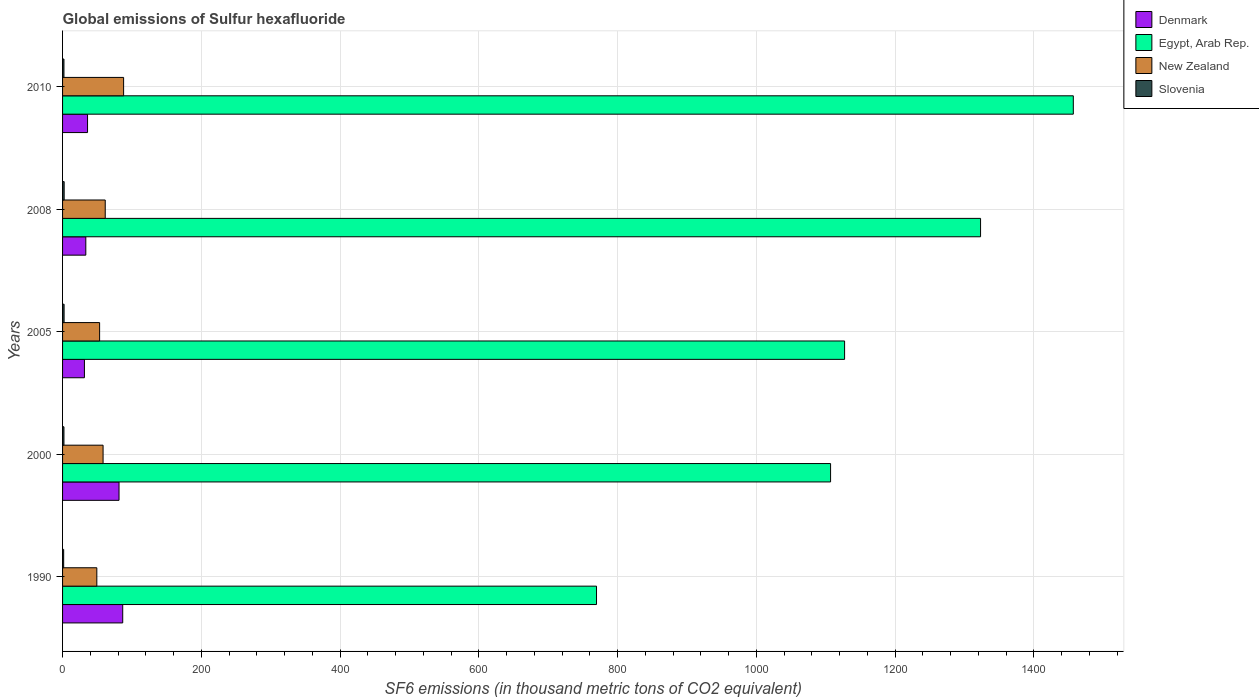How many different coloured bars are there?
Provide a succinct answer. 4. How many groups of bars are there?
Keep it short and to the point. 5. What is the label of the 1st group of bars from the top?
Your answer should be very brief. 2010. Across all years, what is the maximum global emissions of Sulfur hexafluoride in Slovenia?
Provide a succinct answer. 2.3. Across all years, what is the minimum global emissions of Sulfur hexafluoride in New Zealand?
Provide a succinct answer. 49.4. In which year was the global emissions of Sulfur hexafluoride in New Zealand maximum?
Offer a very short reply. 2010. What is the total global emissions of Sulfur hexafluoride in Egypt, Arab Rep. in the graph?
Offer a very short reply. 5784.4. What is the difference between the global emissions of Sulfur hexafluoride in Egypt, Arab Rep. in 1990 and the global emissions of Sulfur hexafluoride in Denmark in 2010?
Keep it short and to the point. 733.7. What is the average global emissions of Sulfur hexafluoride in Slovenia per year?
Offer a terse response. 2.02. In the year 2010, what is the difference between the global emissions of Sulfur hexafluoride in Denmark and global emissions of Sulfur hexafluoride in Egypt, Arab Rep.?
Offer a terse response. -1421. In how many years, is the global emissions of Sulfur hexafluoride in Denmark greater than 600 thousand metric tons?
Offer a very short reply. 0. What is the ratio of the global emissions of Sulfur hexafluoride in Slovenia in 2000 to that in 2005?
Provide a short and direct response. 0.91. Is the global emissions of Sulfur hexafluoride in Slovenia in 2008 less than that in 2010?
Provide a succinct answer. No. Is the difference between the global emissions of Sulfur hexafluoride in Denmark in 2000 and 2008 greater than the difference between the global emissions of Sulfur hexafluoride in Egypt, Arab Rep. in 2000 and 2008?
Keep it short and to the point. Yes. What is the difference between the highest and the second highest global emissions of Sulfur hexafluoride in Egypt, Arab Rep.?
Your response must be concise. 133.7. What is the difference between the highest and the lowest global emissions of Sulfur hexafluoride in Egypt, Arab Rep.?
Ensure brevity in your answer.  687.3. In how many years, is the global emissions of Sulfur hexafluoride in Slovenia greater than the average global emissions of Sulfur hexafluoride in Slovenia taken over all years?
Give a very brief answer. 2. Is the sum of the global emissions of Sulfur hexafluoride in Slovenia in 1990 and 2008 greater than the maximum global emissions of Sulfur hexafluoride in New Zealand across all years?
Offer a terse response. No. What does the 4th bar from the top in 2010 represents?
Ensure brevity in your answer.  Denmark. What does the 3rd bar from the bottom in 1990 represents?
Give a very brief answer. New Zealand. Is it the case that in every year, the sum of the global emissions of Sulfur hexafluoride in Egypt, Arab Rep. and global emissions of Sulfur hexafluoride in New Zealand is greater than the global emissions of Sulfur hexafluoride in Slovenia?
Make the answer very short. Yes. How many bars are there?
Offer a terse response. 20. Are all the bars in the graph horizontal?
Offer a very short reply. Yes. How many years are there in the graph?
Make the answer very short. 5. What is the difference between two consecutive major ticks on the X-axis?
Provide a short and direct response. 200. Are the values on the major ticks of X-axis written in scientific E-notation?
Ensure brevity in your answer.  No. Does the graph contain any zero values?
Your response must be concise. No. Where does the legend appear in the graph?
Your response must be concise. Top right. How many legend labels are there?
Your answer should be compact. 4. How are the legend labels stacked?
Provide a short and direct response. Vertical. What is the title of the graph?
Offer a terse response. Global emissions of Sulfur hexafluoride. What is the label or title of the X-axis?
Give a very brief answer. SF6 emissions (in thousand metric tons of CO2 equivalent). What is the label or title of the Y-axis?
Make the answer very short. Years. What is the SF6 emissions (in thousand metric tons of CO2 equivalent) in Denmark in 1990?
Provide a short and direct response. 86.7. What is the SF6 emissions (in thousand metric tons of CO2 equivalent) in Egypt, Arab Rep. in 1990?
Your answer should be very brief. 769.7. What is the SF6 emissions (in thousand metric tons of CO2 equivalent) of New Zealand in 1990?
Offer a very short reply. 49.4. What is the SF6 emissions (in thousand metric tons of CO2 equivalent) of Slovenia in 1990?
Provide a short and direct response. 1.6. What is the SF6 emissions (in thousand metric tons of CO2 equivalent) of Denmark in 2000?
Give a very brief answer. 81.4. What is the SF6 emissions (in thousand metric tons of CO2 equivalent) in Egypt, Arab Rep. in 2000?
Make the answer very short. 1107.1. What is the SF6 emissions (in thousand metric tons of CO2 equivalent) in New Zealand in 2000?
Keep it short and to the point. 58.4. What is the SF6 emissions (in thousand metric tons of CO2 equivalent) of Denmark in 2005?
Your response must be concise. 31.5. What is the SF6 emissions (in thousand metric tons of CO2 equivalent) in Egypt, Arab Rep. in 2005?
Offer a very short reply. 1127.3. What is the SF6 emissions (in thousand metric tons of CO2 equivalent) of New Zealand in 2005?
Your response must be concise. 53.4. What is the SF6 emissions (in thousand metric tons of CO2 equivalent) of Slovenia in 2005?
Provide a succinct answer. 2.2. What is the SF6 emissions (in thousand metric tons of CO2 equivalent) of Denmark in 2008?
Provide a succinct answer. 33.5. What is the SF6 emissions (in thousand metric tons of CO2 equivalent) in Egypt, Arab Rep. in 2008?
Offer a very short reply. 1323.3. What is the SF6 emissions (in thousand metric tons of CO2 equivalent) in New Zealand in 2008?
Make the answer very short. 61.5. What is the SF6 emissions (in thousand metric tons of CO2 equivalent) of Egypt, Arab Rep. in 2010?
Keep it short and to the point. 1457. What is the SF6 emissions (in thousand metric tons of CO2 equivalent) of Slovenia in 2010?
Offer a very short reply. 2. Across all years, what is the maximum SF6 emissions (in thousand metric tons of CO2 equivalent) of Denmark?
Provide a succinct answer. 86.7. Across all years, what is the maximum SF6 emissions (in thousand metric tons of CO2 equivalent) of Egypt, Arab Rep.?
Provide a short and direct response. 1457. Across all years, what is the minimum SF6 emissions (in thousand metric tons of CO2 equivalent) in Denmark?
Your answer should be very brief. 31.5. Across all years, what is the minimum SF6 emissions (in thousand metric tons of CO2 equivalent) of Egypt, Arab Rep.?
Provide a short and direct response. 769.7. Across all years, what is the minimum SF6 emissions (in thousand metric tons of CO2 equivalent) in New Zealand?
Make the answer very short. 49.4. What is the total SF6 emissions (in thousand metric tons of CO2 equivalent) of Denmark in the graph?
Offer a very short reply. 269.1. What is the total SF6 emissions (in thousand metric tons of CO2 equivalent) in Egypt, Arab Rep. in the graph?
Ensure brevity in your answer.  5784.4. What is the total SF6 emissions (in thousand metric tons of CO2 equivalent) of New Zealand in the graph?
Offer a terse response. 310.7. What is the difference between the SF6 emissions (in thousand metric tons of CO2 equivalent) of Denmark in 1990 and that in 2000?
Make the answer very short. 5.3. What is the difference between the SF6 emissions (in thousand metric tons of CO2 equivalent) in Egypt, Arab Rep. in 1990 and that in 2000?
Make the answer very short. -337.4. What is the difference between the SF6 emissions (in thousand metric tons of CO2 equivalent) of New Zealand in 1990 and that in 2000?
Your answer should be compact. -9. What is the difference between the SF6 emissions (in thousand metric tons of CO2 equivalent) of Slovenia in 1990 and that in 2000?
Ensure brevity in your answer.  -0.4. What is the difference between the SF6 emissions (in thousand metric tons of CO2 equivalent) in Denmark in 1990 and that in 2005?
Keep it short and to the point. 55.2. What is the difference between the SF6 emissions (in thousand metric tons of CO2 equivalent) of Egypt, Arab Rep. in 1990 and that in 2005?
Your answer should be very brief. -357.6. What is the difference between the SF6 emissions (in thousand metric tons of CO2 equivalent) in New Zealand in 1990 and that in 2005?
Provide a short and direct response. -4. What is the difference between the SF6 emissions (in thousand metric tons of CO2 equivalent) in Slovenia in 1990 and that in 2005?
Provide a succinct answer. -0.6. What is the difference between the SF6 emissions (in thousand metric tons of CO2 equivalent) in Denmark in 1990 and that in 2008?
Offer a terse response. 53.2. What is the difference between the SF6 emissions (in thousand metric tons of CO2 equivalent) of Egypt, Arab Rep. in 1990 and that in 2008?
Your response must be concise. -553.6. What is the difference between the SF6 emissions (in thousand metric tons of CO2 equivalent) of New Zealand in 1990 and that in 2008?
Keep it short and to the point. -12.1. What is the difference between the SF6 emissions (in thousand metric tons of CO2 equivalent) of Slovenia in 1990 and that in 2008?
Your answer should be very brief. -0.7. What is the difference between the SF6 emissions (in thousand metric tons of CO2 equivalent) of Denmark in 1990 and that in 2010?
Make the answer very short. 50.7. What is the difference between the SF6 emissions (in thousand metric tons of CO2 equivalent) of Egypt, Arab Rep. in 1990 and that in 2010?
Offer a terse response. -687.3. What is the difference between the SF6 emissions (in thousand metric tons of CO2 equivalent) of New Zealand in 1990 and that in 2010?
Make the answer very short. -38.6. What is the difference between the SF6 emissions (in thousand metric tons of CO2 equivalent) in Slovenia in 1990 and that in 2010?
Your response must be concise. -0.4. What is the difference between the SF6 emissions (in thousand metric tons of CO2 equivalent) of Denmark in 2000 and that in 2005?
Give a very brief answer. 49.9. What is the difference between the SF6 emissions (in thousand metric tons of CO2 equivalent) in Egypt, Arab Rep. in 2000 and that in 2005?
Your answer should be very brief. -20.2. What is the difference between the SF6 emissions (in thousand metric tons of CO2 equivalent) in Slovenia in 2000 and that in 2005?
Offer a terse response. -0.2. What is the difference between the SF6 emissions (in thousand metric tons of CO2 equivalent) of Denmark in 2000 and that in 2008?
Provide a short and direct response. 47.9. What is the difference between the SF6 emissions (in thousand metric tons of CO2 equivalent) in Egypt, Arab Rep. in 2000 and that in 2008?
Ensure brevity in your answer.  -216.2. What is the difference between the SF6 emissions (in thousand metric tons of CO2 equivalent) in New Zealand in 2000 and that in 2008?
Provide a short and direct response. -3.1. What is the difference between the SF6 emissions (in thousand metric tons of CO2 equivalent) in Slovenia in 2000 and that in 2008?
Provide a succinct answer. -0.3. What is the difference between the SF6 emissions (in thousand metric tons of CO2 equivalent) of Denmark in 2000 and that in 2010?
Offer a very short reply. 45.4. What is the difference between the SF6 emissions (in thousand metric tons of CO2 equivalent) of Egypt, Arab Rep. in 2000 and that in 2010?
Make the answer very short. -349.9. What is the difference between the SF6 emissions (in thousand metric tons of CO2 equivalent) in New Zealand in 2000 and that in 2010?
Provide a short and direct response. -29.6. What is the difference between the SF6 emissions (in thousand metric tons of CO2 equivalent) of Slovenia in 2000 and that in 2010?
Make the answer very short. 0. What is the difference between the SF6 emissions (in thousand metric tons of CO2 equivalent) of Egypt, Arab Rep. in 2005 and that in 2008?
Provide a succinct answer. -196. What is the difference between the SF6 emissions (in thousand metric tons of CO2 equivalent) of New Zealand in 2005 and that in 2008?
Provide a succinct answer. -8.1. What is the difference between the SF6 emissions (in thousand metric tons of CO2 equivalent) in Denmark in 2005 and that in 2010?
Your answer should be compact. -4.5. What is the difference between the SF6 emissions (in thousand metric tons of CO2 equivalent) of Egypt, Arab Rep. in 2005 and that in 2010?
Your answer should be very brief. -329.7. What is the difference between the SF6 emissions (in thousand metric tons of CO2 equivalent) of New Zealand in 2005 and that in 2010?
Provide a succinct answer. -34.6. What is the difference between the SF6 emissions (in thousand metric tons of CO2 equivalent) in Slovenia in 2005 and that in 2010?
Provide a succinct answer. 0.2. What is the difference between the SF6 emissions (in thousand metric tons of CO2 equivalent) of Denmark in 2008 and that in 2010?
Offer a terse response. -2.5. What is the difference between the SF6 emissions (in thousand metric tons of CO2 equivalent) in Egypt, Arab Rep. in 2008 and that in 2010?
Make the answer very short. -133.7. What is the difference between the SF6 emissions (in thousand metric tons of CO2 equivalent) of New Zealand in 2008 and that in 2010?
Offer a terse response. -26.5. What is the difference between the SF6 emissions (in thousand metric tons of CO2 equivalent) of Denmark in 1990 and the SF6 emissions (in thousand metric tons of CO2 equivalent) of Egypt, Arab Rep. in 2000?
Your answer should be very brief. -1020.4. What is the difference between the SF6 emissions (in thousand metric tons of CO2 equivalent) of Denmark in 1990 and the SF6 emissions (in thousand metric tons of CO2 equivalent) of New Zealand in 2000?
Ensure brevity in your answer.  28.3. What is the difference between the SF6 emissions (in thousand metric tons of CO2 equivalent) of Denmark in 1990 and the SF6 emissions (in thousand metric tons of CO2 equivalent) of Slovenia in 2000?
Give a very brief answer. 84.7. What is the difference between the SF6 emissions (in thousand metric tons of CO2 equivalent) in Egypt, Arab Rep. in 1990 and the SF6 emissions (in thousand metric tons of CO2 equivalent) in New Zealand in 2000?
Offer a terse response. 711.3. What is the difference between the SF6 emissions (in thousand metric tons of CO2 equivalent) in Egypt, Arab Rep. in 1990 and the SF6 emissions (in thousand metric tons of CO2 equivalent) in Slovenia in 2000?
Your answer should be compact. 767.7. What is the difference between the SF6 emissions (in thousand metric tons of CO2 equivalent) in New Zealand in 1990 and the SF6 emissions (in thousand metric tons of CO2 equivalent) in Slovenia in 2000?
Provide a succinct answer. 47.4. What is the difference between the SF6 emissions (in thousand metric tons of CO2 equivalent) of Denmark in 1990 and the SF6 emissions (in thousand metric tons of CO2 equivalent) of Egypt, Arab Rep. in 2005?
Your answer should be very brief. -1040.6. What is the difference between the SF6 emissions (in thousand metric tons of CO2 equivalent) in Denmark in 1990 and the SF6 emissions (in thousand metric tons of CO2 equivalent) in New Zealand in 2005?
Give a very brief answer. 33.3. What is the difference between the SF6 emissions (in thousand metric tons of CO2 equivalent) of Denmark in 1990 and the SF6 emissions (in thousand metric tons of CO2 equivalent) of Slovenia in 2005?
Offer a terse response. 84.5. What is the difference between the SF6 emissions (in thousand metric tons of CO2 equivalent) of Egypt, Arab Rep. in 1990 and the SF6 emissions (in thousand metric tons of CO2 equivalent) of New Zealand in 2005?
Your response must be concise. 716.3. What is the difference between the SF6 emissions (in thousand metric tons of CO2 equivalent) of Egypt, Arab Rep. in 1990 and the SF6 emissions (in thousand metric tons of CO2 equivalent) of Slovenia in 2005?
Offer a very short reply. 767.5. What is the difference between the SF6 emissions (in thousand metric tons of CO2 equivalent) in New Zealand in 1990 and the SF6 emissions (in thousand metric tons of CO2 equivalent) in Slovenia in 2005?
Your answer should be compact. 47.2. What is the difference between the SF6 emissions (in thousand metric tons of CO2 equivalent) in Denmark in 1990 and the SF6 emissions (in thousand metric tons of CO2 equivalent) in Egypt, Arab Rep. in 2008?
Offer a very short reply. -1236.6. What is the difference between the SF6 emissions (in thousand metric tons of CO2 equivalent) in Denmark in 1990 and the SF6 emissions (in thousand metric tons of CO2 equivalent) in New Zealand in 2008?
Make the answer very short. 25.2. What is the difference between the SF6 emissions (in thousand metric tons of CO2 equivalent) of Denmark in 1990 and the SF6 emissions (in thousand metric tons of CO2 equivalent) of Slovenia in 2008?
Your response must be concise. 84.4. What is the difference between the SF6 emissions (in thousand metric tons of CO2 equivalent) in Egypt, Arab Rep. in 1990 and the SF6 emissions (in thousand metric tons of CO2 equivalent) in New Zealand in 2008?
Make the answer very short. 708.2. What is the difference between the SF6 emissions (in thousand metric tons of CO2 equivalent) in Egypt, Arab Rep. in 1990 and the SF6 emissions (in thousand metric tons of CO2 equivalent) in Slovenia in 2008?
Offer a terse response. 767.4. What is the difference between the SF6 emissions (in thousand metric tons of CO2 equivalent) in New Zealand in 1990 and the SF6 emissions (in thousand metric tons of CO2 equivalent) in Slovenia in 2008?
Give a very brief answer. 47.1. What is the difference between the SF6 emissions (in thousand metric tons of CO2 equivalent) in Denmark in 1990 and the SF6 emissions (in thousand metric tons of CO2 equivalent) in Egypt, Arab Rep. in 2010?
Your response must be concise. -1370.3. What is the difference between the SF6 emissions (in thousand metric tons of CO2 equivalent) of Denmark in 1990 and the SF6 emissions (in thousand metric tons of CO2 equivalent) of Slovenia in 2010?
Provide a short and direct response. 84.7. What is the difference between the SF6 emissions (in thousand metric tons of CO2 equivalent) of Egypt, Arab Rep. in 1990 and the SF6 emissions (in thousand metric tons of CO2 equivalent) of New Zealand in 2010?
Provide a short and direct response. 681.7. What is the difference between the SF6 emissions (in thousand metric tons of CO2 equivalent) in Egypt, Arab Rep. in 1990 and the SF6 emissions (in thousand metric tons of CO2 equivalent) in Slovenia in 2010?
Provide a succinct answer. 767.7. What is the difference between the SF6 emissions (in thousand metric tons of CO2 equivalent) in New Zealand in 1990 and the SF6 emissions (in thousand metric tons of CO2 equivalent) in Slovenia in 2010?
Your answer should be compact. 47.4. What is the difference between the SF6 emissions (in thousand metric tons of CO2 equivalent) in Denmark in 2000 and the SF6 emissions (in thousand metric tons of CO2 equivalent) in Egypt, Arab Rep. in 2005?
Provide a succinct answer. -1045.9. What is the difference between the SF6 emissions (in thousand metric tons of CO2 equivalent) of Denmark in 2000 and the SF6 emissions (in thousand metric tons of CO2 equivalent) of Slovenia in 2005?
Provide a short and direct response. 79.2. What is the difference between the SF6 emissions (in thousand metric tons of CO2 equivalent) in Egypt, Arab Rep. in 2000 and the SF6 emissions (in thousand metric tons of CO2 equivalent) in New Zealand in 2005?
Ensure brevity in your answer.  1053.7. What is the difference between the SF6 emissions (in thousand metric tons of CO2 equivalent) in Egypt, Arab Rep. in 2000 and the SF6 emissions (in thousand metric tons of CO2 equivalent) in Slovenia in 2005?
Provide a short and direct response. 1104.9. What is the difference between the SF6 emissions (in thousand metric tons of CO2 equivalent) of New Zealand in 2000 and the SF6 emissions (in thousand metric tons of CO2 equivalent) of Slovenia in 2005?
Give a very brief answer. 56.2. What is the difference between the SF6 emissions (in thousand metric tons of CO2 equivalent) of Denmark in 2000 and the SF6 emissions (in thousand metric tons of CO2 equivalent) of Egypt, Arab Rep. in 2008?
Your answer should be very brief. -1241.9. What is the difference between the SF6 emissions (in thousand metric tons of CO2 equivalent) in Denmark in 2000 and the SF6 emissions (in thousand metric tons of CO2 equivalent) in Slovenia in 2008?
Give a very brief answer. 79.1. What is the difference between the SF6 emissions (in thousand metric tons of CO2 equivalent) in Egypt, Arab Rep. in 2000 and the SF6 emissions (in thousand metric tons of CO2 equivalent) in New Zealand in 2008?
Your response must be concise. 1045.6. What is the difference between the SF6 emissions (in thousand metric tons of CO2 equivalent) of Egypt, Arab Rep. in 2000 and the SF6 emissions (in thousand metric tons of CO2 equivalent) of Slovenia in 2008?
Offer a terse response. 1104.8. What is the difference between the SF6 emissions (in thousand metric tons of CO2 equivalent) in New Zealand in 2000 and the SF6 emissions (in thousand metric tons of CO2 equivalent) in Slovenia in 2008?
Make the answer very short. 56.1. What is the difference between the SF6 emissions (in thousand metric tons of CO2 equivalent) in Denmark in 2000 and the SF6 emissions (in thousand metric tons of CO2 equivalent) in Egypt, Arab Rep. in 2010?
Provide a short and direct response. -1375.6. What is the difference between the SF6 emissions (in thousand metric tons of CO2 equivalent) in Denmark in 2000 and the SF6 emissions (in thousand metric tons of CO2 equivalent) in New Zealand in 2010?
Give a very brief answer. -6.6. What is the difference between the SF6 emissions (in thousand metric tons of CO2 equivalent) of Denmark in 2000 and the SF6 emissions (in thousand metric tons of CO2 equivalent) of Slovenia in 2010?
Offer a very short reply. 79.4. What is the difference between the SF6 emissions (in thousand metric tons of CO2 equivalent) in Egypt, Arab Rep. in 2000 and the SF6 emissions (in thousand metric tons of CO2 equivalent) in New Zealand in 2010?
Keep it short and to the point. 1019.1. What is the difference between the SF6 emissions (in thousand metric tons of CO2 equivalent) of Egypt, Arab Rep. in 2000 and the SF6 emissions (in thousand metric tons of CO2 equivalent) of Slovenia in 2010?
Provide a short and direct response. 1105.1. What is the difference between the SF6 emissions (in thousand metric tons of CO2 equivalent) in New Zealand in 2000 and the SF6 emissions (in thousand metric tons of CO2 equivalent) in Slovenia in 2010?
Make the answer very short. 56.4. What is the difference between the SF6 emissions (in thousand metric tons of CO2 equivalent) of Denmark in 2005 and the SF6 emissions (in thousand metric tons of CO2 equivalent) of Egypt, Arab Rep. in 2008?
Offer a terse response. -1291.8. What is the difference between the SF6 emissions (in thousand metric tons of CO2 equivalent) of Denmark in 2005 and the SF6 emissions (in thousand metric tons of CO2 equivalent) of New Zealand in 2008?
Your answer should be compact. -30. What is the difference between the SF6 emissions (in thousand metric tons of CO2 equivalent) in Denmark in 2005 and the SF6 emissions (in thousand metric tons of CO2 equivalent) in Slovenia in 2008?
Provide a succinct answer. 29.2. What is the difference between the SF6 emissions (in thousand metric tons of CO2 equivalent) in Egypt, Arab Rep. in 2005 and the SF6 emissions (in thousand metric tons of CO2 equivalent) in New Zealand in 2008?
Provide a short and direct response. 1065.8. What is the difference between the SF6 emissions (in thousand metric tons of CO2 equivalent) of Egypt, Arab Rep. in 2005 and the SF6 emissions (in thousand metric tons of CO2 equivalent) of Slovenia in 2008?
Offer a very short reply. 1125. What is the difference between the SF6 emissions (in thousand metric tons of CO2 equivalent) in New Zealand in 2005 and the SF6 emissions (in thousand metric tons of CO2 equivalent) in Slovenia in 2008?
Make the answer very short. 51.1. What is the difference between the SF6 emissions (in thousand metric tons of CO2 equivalent) of Denmark in 2005 and the SF6 emissions (in thousand metric tons of CO2 equivalent) of Egypt, Arab Rep. in 2010?
Give a very brief answer. -1425.5. What is the difference between the SF6 emissions (in thousand metric tons of CO2 equivalent) in Denmark in 2005 and the SF6 emissions (in thousand metric tons of CO2 equivalent) in New Zealand in 2010?
Keep it short and to the point. -56.5. What is the difference between the SF6 emissions (in thousand metric tons of CO2 equivalent) in Denmark in 2005 and the SF6 emissions (in thousand metric tons of CO2 equivalent) in Slovenia in 2010?
Offer a terse response. 29.5. What is the difference between the SF6 emissions (in thousand metric tons of CO2 equivalent) in Egypt, Arab Rep. in 2005 and the SF6 emissions (in thousand metric tons of CO2 equivalent) in New Zealand in 2010?
Your response must be concise. 1039.3. What is the difference between the SF6 emissions (in thousand metric tons of CO2 equivalent) in Egypt, Arab Rep. in 2005 and the SF6 emissions (in thousand metric tons of CO2 equivalent) in Slovenia in 2010?
Provide a succinct answer. 1125.3. What is the difference between the SF6 emissions (in thousand metric tons of CO2 equivalent) in New Zealand in 2005 and the SF6 emissions (in thousand metric tons of CO2 equivalent) in Slovenia in 2010?
Your answer should be very brief. 51.4. What is the difference between the SF6 emissions (in thousand metric tons of CO2 equivalent) of Denmark in 2008 and the SF6 emissions (in thousand metric tons of CO2 equivalent) of Egypt, Arab Rep. in 2010?
Offer a very short reply. -1423.5. What is the difference between the SF6 emissions (in thousand metric tons of CO2 equivalent) of Denmark in 2008 and the SF6 emissions (in thousand metric tons of CO2 equivalent) of New Zealand in 2010?
Give a very brief answer. -54.5. What is the difference between the SF6 emissions (in thousand metric tons of CO2 equivalent) of Denmark in 2008 and the SF6 emissions (in thousand metric tons of CO2 equivalent) of Slovenia in 2010?
Your response must be concise. 31.5. What is the difference between the SF6 emissions (in thousand metric tons of CO2 equivalent) in Egypt, Arab Rep. in 2008 and the SF6 emissions (in thousand metric tons of CO2 equivalent) in New Zealand in 2010?
Your answer should be very brief. 1235.3. What is the difference between the SF6 emissions (in thousand metric tons of CO2 equivalent) of Egypt, Arab Rep. in 2008 and the SF6 emissions (in thousand metric tons of CO2 equivalent) of Slovenia in 2010?
Your answer should be compact. 1321.3. What is the difference between the SF6 emissions (in thousand metric tons of CO2 equivalent) in New Zealand in 2008 and the SF6 emissions (in thousand metric tons of CO2 equivalent) in Slovenia in 2010?
Your answer should be very brief. 59.5. What is the average SF6 emissions (in thousand metric tons of CO2 equivalent) in Denmark per year?
Give a very brief answer. 53.82. What is the average SF6 emissions (in thousand metric tons of CO2 equivalent) of Egypt, Arab Rep. per year?
Offer a terse response. 1156.88. What is the average SF6 emissions (in thousand metric tons of CO2 equivalent) of New Zealand per year?
Provide a succinct answer. 62.14. What is the average SF6 emissions (in thousand metric tons of CO2 equivalent) in Slovenia per year?
Keep it short and to the point. 2.02. In the year 1990, what is the difference between the SF6 emissions (in thousand metric tons of CO2 equivalent) of Denmark and SF6 emissions (in thousand metric tons of CO2 equivalent) of Egypt, Arab Rep.?
Make the answer very short. -683. In the year 1990, what is the difference between the SF6 emissions (in thousand metric tons of CO2 equivalent) of Denmark and SF6 emissions (in thousand metric tons of CO2 equivalent) of New Zealand?
Provide a short and direct response. 37.3. In the year 1990, what is the difference between the SF6 emissions (in thousand metric tons of CO2 equivalent) of Denmark and SF6 emissions (in thousand metric tons of CO2 equivalent) of Slovenia?
Keep it short and to the point. 85.1. In the year 1990, what is the difference between the SF6 emissions (in thousand metric tons of CO2 equivalent) in Egypt, Arab Rep. and SF6 emissions (in thousand metric tons of CO2 equivalent) in New Zealand?
Provide a succinct answer. 720.3. In the year 1990, what is the difference between the SF6 emissions (in thousand metric tons of CO2 equivalent) in Egypt, Arab Rep. and SF6 emissions (in thousand metric tons of CO2 equivalent) in Slovenia?
Offer a very short reply. 768.1. In the year 1990, what is the difference between the SF6 emissions (in thousand metric tons of CO2 equivalent) of New Zealand and SF6 emissions (in thousand metric tons of CO2 equivalent) of Slovenia?
Provide a succinct answer. 47.8. In the year 2000, what is the difference between the SF6 emissions (in thousand metric tons of CO2 equivalent) in Denmark and SF6 emissions (in thousand metric tons of CO2 equivalent) in Egypt, Arab Rep.?
Your answer should be compact. -1025.7. In the year 2000, what is the difference between the SF6 emissions (in thousand metric tons of CO2 equivalent) in Denmark and SF6 emissions (in thousand metric tons of CO2 equivalent) in New Zealand?
Keep it short and to the point. 23. In the year 2000, what is the difference between the SF6 emissions (in thousand metric tons of CO2 equivalent) in Denmark and SF6 emissions (in thousand metric tons of CO2 equivalent) in Slovenia?
Provide a short and direct response. 79.4. In the year 2000, what is the difference between the SF6 emissions (in thousand metric tons of CO2 equivalent) in Egypt, Arab Rep. and SF6 emissions (in thousand metric tons of CO2 equivalent) in New Zealand?
Your answer should be compact. 1048.7. In the year 2000, what is the difference between the SF6 emissions (in thousand metric tons of CO2 equivalent) in Egypt, Arab Rep. and SF6 emissions (in thousand metric tons of CO2 equivalent) in Slovenia?
Give a very brief answer. 1105.1. In the year 2000, what is the difference between the SF6 emissions (in thousand metric tons of CO2 equivalent) of New Zealand and SF6 emissions (in thousand metric tons of CO2 equivalent) of Slovenia?
Offer a terse response. 56.4. In the year 2005, what is the difference between the SF6 emissions (in thousand metric tons of CO2 equivalent) in Denmark and SF6 emissions (in thousand metric tons of CO2 equivalent) in Egypt, Arab Rep.?
Make the answer very short. -1095.8. In the year 2005, what is the difference between the SF6 emissions (in thousand metric tons of CO2 equivalent) of Denmark and SF6 emissions (in thousand metric tons of CO2 equivalent) of New Zealand?
Your answer should be compact. -21.9. In the year 2005, what is the difference between the SF6 emissions (in thousand metric tons of CO2 equivalent) in Denmark and SF6 emissions (in thousand metric tons of CO2 equivalent) in Slovenia?
Make the answer very short. 29.3. In the year 2005, what is the difference between the SF6 emissions (in thousand metric tons of CO2 equivalent) of Egypt, Arab Rep. and SF6 emissions (in thousand metric tons of CO2 equivalent) of New Zealand?
Your answer should be compact. 1073.9. In the year 2005, what is the difference between the SF6 emissions (in thousand metric tons of CO2 equivalent) of Egypt, Arab Rep. and SF6 emissions (in thousand metric tons of CO2 equivalent) of Slovenia?
Keep it short and to the point. 1125.1. In the year 2005, what is the difference between the SF6 emissions (in thousand metric tons of CO2 equivalent) of New Zealand and SF6 emissions (in thousand metric tons of CO2 equivalent) of Slovenia?
Provide a succinct answer. 51.2. In the year 2008, what is the difference between the SF6 emissions (in thousand metric tons of CO2 equivalent) of Denmark and SF6 emissions (in thousand metric tons of CO2 equivalent) of Egypt, Arab Rep.?
Your answer should be compact. -1289.8. In the year 2008, what is the difference between the SF6 emissions (in thousand metric tons of CO2 equivalent) of Denmark and SF6 emissions (in thousand metric tons of CO2 equivalent) of Slovenia?
Give a very brief answer. 31.2. In the year 2008, what is the difference between the SF6 emissions (in thousand metric tons of CO2 equivalent) in Egypt, Arab Rep. and SF6 emissions (in thousand metric tons of CO2 equivalent) in New Zealand?
Offer a very short reply. 1261.8. In the year 2008, what is the difference between the SF6 emissions (in thousand metric tons of CO2 equivalent) in Egypt, Arab Rep. and SF6 emissions (in thousand metric tons of CO2 equivalent) in Slovenia?
Provide a succinct answer. 1321. In the year 2008, what is the difference between the SF6 emissions (in thousand metric tons of CO2 equivalent) in New Zealand and SF6 emissions (in thousand metric tons of CO2 equivalent) in Slovenia?
Keep it short and to the point. 59.2. In the year 2010, what is the difference between the SF6 emissions (in thousand metric tons of CO2 equivalent) in Denmark and SF6 emissions (in thousand metric tons of CO2 equivalent) in Egypt, Arab Rep.?
Offer a terse response. -1421. In the year 2010, what is the difference between the SF6 emissions (in thousand metric tons of CO2 equivalent) in Denmark and SF6 emissions (in thousand metric tons of CO2 equivalent) in New Zealand?
Provide a succinct answer. -52. In the year 2010, what is the difference between the SF6 emissions (in thousand metric tons of CO2 equivalent) of Egypt, Arab Rep. and SF6 emissions (in thousand metric tons of CO2 equivalent) of New Zealand?
Offer a very short reply. 1369. In the year 2010, what is the difference between the SF6 emissions (in thousand metric tons of CO2 equivalent) of Egypt, Arab Rep. and SF6 emissions (in thousand metric tons of CO2 equivalent) of Slovenia?
Your answer should be very brief. 1455. What is the ratio of the SF6 emissions (in thousand metric tons of CO2 equivalent) of Denmark in 1990 to that in 2000?
Provide a succinct answer. 1.07. What is the ratio of the SF6 emissions (in thousand metric tons of CO2 equivalent) in Egypt, Arab Rep. in 1990 to that in 2000?
Keep it short and to the point. 0.7. What is the ratio of the SF6 emissions (in thousand metric tons of CO2 equivalent) in New Zealand in 1990 to that in 2000?
Provide a short and direct response. 0.85. What is the ratio of the SF6 emissions (in thousand metric tons of CO2 equivalent) of Denmark in 1990 to that in 2005?
Provide a succinct answer. 2.75. What is the ratio of the SF6 emissions (in thousand metric tons of CO2 equivalent) of Egypt, Arab Rep. in 1990 to that in 2005?
Make the answer very short. 0.68. What is the ratio of the SF6 emissions (in thousand metric tons of CO2 equivalent) in New Zealand in 1990 to that in 2005?
Offer a very short reply. 0.93. What is the ratio of the SF6 emissions (in thousand metric tons of CO2 equivalent) in Slovenia in 1990 to that in 2005?
Offer a very short reply. 0.73. What is the ratio of the SF6 emissions (in thousand metric tons of CO2 equivalent) of Denmark in 1990 to that in 2008?
Ensure brevity in your answer.  2.59. What is the ratio of the SF6 emissions (in thousand metric tons of CO2 equivalent) in Egypt, Arab Rep. in 1990 to that in 2008?
Your response must be concise. 0.58. What is the ratio of the SF6 emissions (in thousand metric tons of CO2 equivalent) of New Zealand in 1990 to that in 2008?
Ensure brevity in your answer.  0.8. What is the ratio of the SF6 emissions (in thousand metric tons of CO2 equivalent) in Slovenia in 1990 to that in 2008?
Your response must be concise. 0.7. What is the ratio of the SF6 emissions (in thousand metric tons of CO2 equivalent) of Denmark in 1990 to that in 2010?
Your answer should be compact. 2.41. What is the ratio of the SF6 emissions (in thousand metric tons of CO2 equivalent) in Egypt, Arab Rep. in 1990 to that in 2010?
Provide a short and direct response. 0.53. What is the ratio of the SF6 emissions (in thousand metric tons of CO2 equivalent) of New Zealand in 1990 to that in 2010?
Ensure brevity in your answer.  0.56. What is the ratio of the SF6 emissions (in thousand metric tons of CO2 equivalent) of Denmark in 2000 to that in 2005?
Your response must be concise. 2.58. What is the ratio of the SF6 emissions (in thousand metric tons of CO2 equivalent) in Egypt, Arab Rep. in 2000 to that in 2005?
Give a very brief answer. 0.98. What is the ratio of the SF6 emissions (in thousand metric tons of CO2 equivalent) of New Zealand in 2000 to that in 2005?
Provide a succinct answer. 1.09. What is the ratio of the SF6 emissions (in thousand metric tons of CO2 equivalent) of Denmark in 2000 to that in 2008?
Make the answer very short. 2.43. What is the ratio of the SF6 emissions (in thousand metric tons of CO2 equivalent) in Egypt, Arab Rep. in 2000 to that in 2008?
Provide a short and direct response. 0.84. What is the ratio of the SF6 emissions (in thousand metric tons of CO2 equivalent) of New Zealand in 2000 to that in 2008?
Your response must be concise. 0.95. What is the ratio of the SF6 emissions (in thousand metric tons of CO2 equivalent) of Slovenia in 2000 to that in 2008?
Offer a terse response. 0.87. What is the ratio of the SF6 emissions (in thousand metric tons of CO2 equivalent) of Denmark in 2000 to that in 2010?
Ensure brevity in your answer.  2.26. What is the ratio of the SF6 emissions (in thousand metric tons of CO2 equivalent) in Egypt, Arab Rep. in 2000 to that in 2010?
Your answer should be compact. 0.76. What is the ratio of the SF6 emissions (in thousand metric tons of CO2 equivalent) of New Zealand in 2000 to that in 2010?
Make the answer very short. 0.66. What is the ratio of the SF6 emissions (in thousand metric tons of CO2 equivalent) of Slovenia in 2000 to that in 2010?
Offer a terse response. 1. What is the ratio of the SF6 emissions (in thousand metric tons of CO2 equivalent) in Denmark in 2005 to that in 2008?
Give a very brief answer. 0.94. What is the ratio of the SF6 emissions (in thousand metric tons of CO2 equivalent) in Egypt, Arab Rep. in 2005 to that in 2008?
Provide a succinct answer. 0.85. What is the ratio of the SF6 emissions (in thousand metric tons of CO2 equivalent) of New Zealand in 2005 to that in 2008?
Offer a terse response. 0.87. What is the ratio of the SF6 emissions (in thousand metric tons of CO2 equivalent) in Slovenia in 2005 to that in 2008?
Offer a very short reply. 0.96. What is the ratio of the SF6 emissions (in thousand metric tons of CO2 equivalent) in Denmark in 2005 to that in 2010?
Offer a terse response. 0.88. What is the ratio of the SF6 emissions (in thousand metric tons of CO2 equivalent) of Egypt, Arab Rep. in 2005 to that in 2010?
Offer a terse response. 0.77. What is the ratio of the SF6 emissions (in thousand metric tons of CO2 equivalent) of New Zealand in 2005 to that in 2010?
Your answer should be very brief. 0.61. What is the ratio of the SF6 emissions (in thousand metric tons of CO2 equivalent) in Denmark in 2008 to that in 2010?
Make the answer very short. 0.93. What is the ratio of the SF6 emissions (in thousand metric tons of CO2 equivalent) in Egypt, Arab Rep. in 2008 to that in 2010?
Your response must be concise. 0.91. What is the ratio of the SF6 emissions (in thousand metric tons of CO2 equivalent) in New Zealand in 2008 to that in 2010?
Give a very brief answer. 0.7. What is the ratio of the SF6 emissions (in thousand metric tons of CO2 equivalent) in Slovenia in 2008 to that in 2010?
Provide a short and direct response. 1.15. What is the difference between the highest and the second highest SF6 emissions (in thousand metric tons of CO2 equivalent) in Denmark?
Provide a succinct answer. 5.3. What is the difference between the highest and the second highest SF6 emissions (in thousand metric tons of CO2 equivalent) of Egypt, Arab Rep.?
Your answer should be compact. 133.7. What is the difference between the highest and the second highest SF6 emissions (in thousand metric tons of CO2 equivalent) in Slovenia?
Keep it short and to the point. 0.1. What is the difference between the highest and the lowest SF6 emissions (in thousand metric tons of CO2 equivalent) of Denmark?
Give a very brief answer. 55.2. What is the difference between the highest and the lowest SF6 emissions (in thousand metric tons of CO2 equivalent) in Egypt, Arab Rep.?
Your response must be concise. 687.3. What is the difference between the highest and the lowest SF6 emissions (in thousand metric tons of CO2 equivalent) in New Zealand?
Your answer should be compact. 38.6. What is the difference between the highest and the lowest SF6 emissions (in thousand metric tons of CO2 equivalent) in Slovenia?
Your response must be concise. 0.7. 